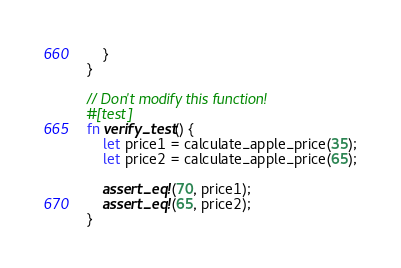<code> <loc_0><loc_0><loc_500><loc_500><_Rust_>    }
}

// Don't modify this function!
#[test]
fn verify_test() {
    let price1 = calculate_apple_price(35);
    let price2 = calculate_apple_price(65);

    assert_eq!(70, price1);
    assert_eq!(65, price2);
}
</code> 